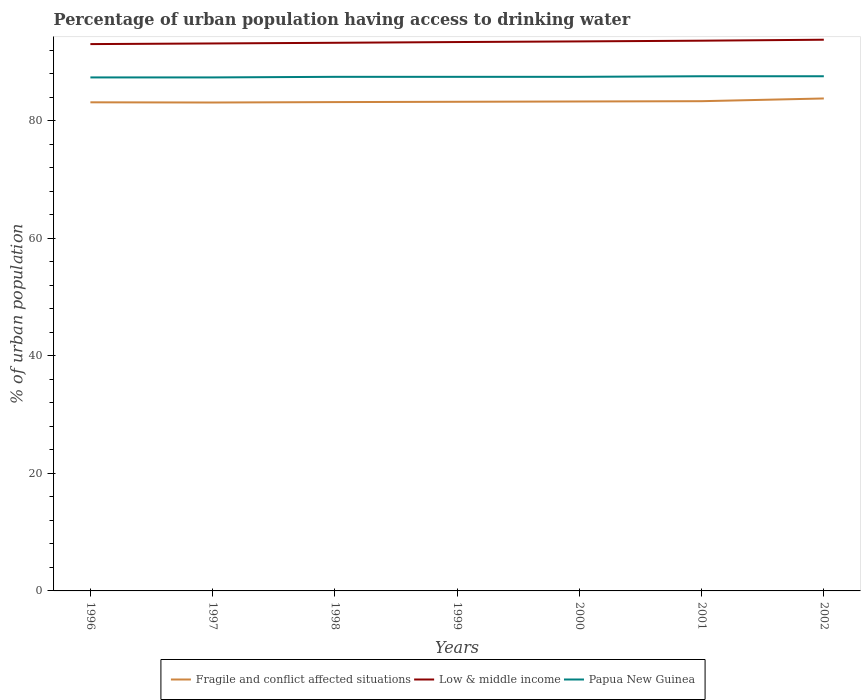Across all years, what is the maximum percentage of urban population having access to drinking water in Fragile and conflict affected situations?
Ensure brevity in your answer.  83.13. What is the total percentage of urban population having access to drinking water in Papua New Guinea in the graph?
Give a very brief answer. -0.1. What is the difference between the highest and the second highest percentage of urban population having access to drinking water in Fragile and conflict affected situations?
Give a very brief answer. 0.69. How many years are there in the graph?
Your answer should be very brief. 7. Does the graph contain grids?
Your response must be concise. No. How many legend labels are there?
Keep it short and to the point. 3. What is the title of the graph?
Your answer should be very brief. Percentage of urban population having access to drinking water. What is the label or title of the X-axis?
Keep it short and to the point. Years. What is the label or title of the Y-axis?
Keep it short and to the point. % of urban population. What is the % of urban population in Fragile and conflict affected situations in 1996?
Provide a short and direct response. 83.16. What is the % of urban population in Low & middle income in 1996?
Your answer should be very brief. 93.07. What is the % of urban population of Papua New Guinea in 1996?
Provide a short and direct response. 87.4. What is the % of urban population in Fragile and conflict affected situations in 1997?
Your answer should be very brief. 83.13. What is the % of urban population in Low & middle income in 1997?
Ensure brevity in your answer.  93.18. What is the % of urban population of Papua New Guinea in 1997?
Offer a terse response. 87.4. What is the % of urban population in Fragile and conflict affected situations in 1998?
Offer a terse response. 83.2. What is the % of urban population in Low & middle income in 1998?
Give a very brief answer. 93.3. What is the % of urban population of Papua New Guinea in 1998?
Your response must be concise. 87.5. What is the % of urban population of Fragile and conflict affected situations in 1999?
Keep it short and to the point. 83.25. What is the % of urban population in Low & middle income in 1999?
Your answer should be compact. 93.42. What is the % of urban population of Papua New Guinea in 1999?
Offer a very short reply. 87.5. What is the % of urban population in Fragile and conflict affected situations in 2000?
Keep it short and to the point. 83.31. What is the % of urban population in Low & middle income in 2000?
Keep it short and to the point. 93.53. What is the % of urban population in Papua New Guinea in 2000?
Keep it short and to the point. 87.5. What is the % of urban population in Fragile and conflict affected situations in 2001?
Keep it short and to the point. 83.35. What is the % of urban population in Low & middle income in 2001?
Your answer should be compact. 93.65. What is the % of urban population in Papua New Guinea in 2001?
Provide a succinct answer. 87.6. What is the % of urban population in Fragile and conflict affected situations in 2002?
Provide a succinct answer. 83.82. What is the % of urban population in Low & middle income in 2002?
Make the answer very short. 93.82. What is the % of urban population of Papua New Guinea in 2002?
Offer a very short reply. 87.6. Across all years, what is the maximum % of urban population in Fragile and conflict affected situations?
Your answer should be very brief. 83.82. Across all years, what is the maximum % of urban population in Low & middle income?
Your answer should be very brief. 93.82. Across all years, what is the maximum % of urban population in Papua New Guinea?
Offer a very short reply. 87.6. Across all years, what is the minimum % of urban population of Fragile and conflict affected situations?
Your answer should be very brief. 83.13. Across all years, what is the minimum % of urban population in Low & middle income?
Your response must be concise. 93.07. Across all years, what is the minimum % of urban population of Papua New Guinea?
Provide a short and direct response. 87.4. What is the total % of urban population in Fragile and conflict affected situations in the graph?
Ensure brevity in your answer.  583.23. What is the total % of urban population in Low & middle income in the graph?
Provide a short and direct response. 653.97. What is the total % of urban population in Papua New Guinea in the graph?
Provide a short and direct response. 612.5. What is the difference between the % of urban population in Fragile and conflict affected situations in 1996 and that in 1997?
Your answer should be compact. 0.04. What is the difference between the % of urban population of Low & middle income in 1996 and that in 1997?
Your answer should be very brief. -0.11. What is the difference between the % of urban population in Papua New Guinea in 1996 and that in 1997?
Give a very brief answer. 0. What is the difference between the % of urban population of Fragile and conflict affected situations in 1996 and that in 1998?
Your answer should be very brief. -0.04. What is the difference between the % of urban population in Low & middle income in 1996 and that in 1998?
Your response must be concise. -0.22. What is the difference between the % of urban population in Fragile and conflict affected situations in 1996 and that in 1999?
Ensure brevity in your answer.  -0.09. What is the difference between the % of urban population of Low & middle income in 1996 and that in 1999?
Ensure brevity in your answer.  -0.35. What is the difference between the % of urban population of Papua New Guinea in 1996 and that in 1999?
Your response must be concise. -0.1. What is the difference between the % of urban population in Fragile and conflict affected situations in 1996 and that in 2000?
Give a very brief answer. -0.14. What is the difference between the % of urban population of Low & middle income in 1996 and that in 2000?
Offer a very short reply. -0.46. What is the difference between the % of urban population in Papua New Guinea in 1996 and that in 2000?
Your answer should be compact. -0.1. What is the difference between the % of urban population of Fragile and conflict affected situations in 1996 and that in 2001?
Your response must be concise. -0.19. What is the difference between the % of urban population in Low & middle income in 1996 and that in 2001?
Your response must be concise. -0.58. What is the difference between the % of urban population in Fragile and conflict affected situations in 1996 and that in 2002?
Give a very brief answer. -0.65. What is the difference between the % of urban population in Low & middle income in 1996 and that in 2002?
Offer a very short reply. -0.75. What is the difference between the % of urban population in Fragile and conflict affected situations in 1997 and that in 1998?
Provide a succinct answer. -0.07. What is the difference between the % of urban population of Low & middle income in 1997 and that in 1998?
Your answer should be very brief. -0.11. What is the difference between the % of urban population in Papua New Guinea in 1997 and that in 1998?
Make the answer very short. -0.1. What is the difference between the % of urban population in Fragile and conflict affected situations in 1997 and that in 1999?
Your answer should be very brief. -0.13. What is the difference between the % of urban population of Low & middle income in 1997 and that in 1999?
Provide a succinct answer. -0.24. What is the difference between the % of urban population in Papua New Guinea in 1997 and that in 1999?
Make the answer very short. -0.1. What is the difference between the % of urban population of Fragile and conflict affected situations in 1997 and that in 2000?
Your answer should be very brief. -0.18. What is the difference between the % of urban population of Low & middle income in 1997 and that in 2000?
Your answer should be compact. -0.35. What is the difference between the % of urban population in Papua New Guinea in 1997 and that in 2000?
Your response must be concise. -0.1. What is the difference between the % of urban population of Fragile and conflict affected situations in 1997 and that in 2001?
Provide a succinct answer. -0.23. What is the difference between the % of urban population in Low & middle income in 1997 and that in 2001?
Your answer should be very brief. -0.47. What is the difference between the % of urban population in Papua New Guinea in 1997 and that in 2001?
Your response must be concise. -0.2. What is the difference between the % of urban population in Fragile and conflict affected situations in 1997 and that in 2002?
Keep it short and to the point. -0.69. What is the difference between the % of urban population in Low & middle income in 1997 and that in 2002?
Give a very brief answer. -0.64. What is the difference between the % of urban population in Papua New Guinea in 1997 and that in 2002?
Offer a very short reply. -0.2. What is the difference between the % of urban population in Fragile and conflict affected situations in 1998 and that in 1999?
Your answer should be very brief. -0.05. What is the difference between the % of urban population in Low & middle income in 1998 and that in 1999?
Make the answer very short. -0.12. What is the difference between the % of urban population in Papua New Guinea in 1998 and that in 1999?
Your answer should be compact. 0. What is the difference between the % of urban population in Fragile and conflict affected situations in 1998 and that in 2000?
Offer a terse response. -0.1. What is the difference between the % of urban population of Low & middle income in 1998 and that in 2000?
Provide a succinct answer. -0.23. What is the difference between the % of urban population in Fragile and conflict affected situations in 1998 and that in 2001?
Keep it short and to the point. -0.15. What is the difference between the % of urban population in Low & middle income in 1998 and that in 2001?
Ensure brevity in your answer.  -0.35. What is the difference between the % of urban population of Papua New Guinea in 1998 and that in 2001?
Provide a succinct answer. -0.1. What is the difference between the % of urban population of Fragile and conflict affected situations in 1998 and that in 2002?
Keep it short and to the point. -0.62. What is the difference between the % of urban population of Low & middle income in 1998 and that in 2002?
Your answer should be compact. -0.52. What is the difference between the % of urban population in Papua New Guinea in 1998 and that in 2002?
Offer a very short reply. -0.1. What is the difference between the % of urban population of Fragile and conflict affected situations in 1999 and that in 2000?
Keep it short and to the point. -0.05. What is the difference between the % of urban population of Low & middle income in 1999 and that in 2000?
Provide a short and direct response. -0.11. What is the difference between the % of urban population of Papua New Guinea in 1999 and that in 2000?
Ensure brevity in your answer.  0. What is the difference between the % of urban population in Fragile and conflict affected situations in 1999 and that in 2001?
Provide a succinct answer. -0.1. What is the difference between the % of urban population in Low & middle income in 1999 and that in 2001?
Ensure brevity in your answer.  -0.23. What is the difference between the % of urban population in Fragile and conflict affected situations in 1999 and that in 2002?
Give a very brief answer. -0.56. What is the difference between the % of urban population in Low & middle income in 1999 and that in 2002?
Provide a short and direct response. -0.4. What is the difference between the % of urban population of Papua New Guinea in 1999 and that in 2002?
Your answer should be very brief. -0.1. What is the difference between the % of urban population in Fragile and conflict affected situations in 2000 and that in 2001?
Your answer should be very brief. -0.05. What is the difference between the % of urban population in Low & middle income in 2000 and that in 2001?
Provide a succinct answer. -0.12. What is the difference between the % of urban population of Fragile and conflict affected situations in 2000 and that in 2002?
Provide a succinct answer. -0.51. What is the difference between the % of urban population in Low & middle income in 2000 and that in 2002?
Your response must be concise. -0.29. What is the difference between the % of urban population in Fragile and conflict affected situations in 2001 and that in 2002?
Provide a short and direct response. -0.46. What is the difference between the % of urban population in Fragile and conflict affected situations in 1996 and the % of urban population in Low & middle income in 1997?
Keep it short and to the point. -10.02. What is the difference between the % of urban population of Fragile and conflict affected situations in 1996 and the % of urban population of Papua New Guinea in 1997?
Provide a succinct answer. -4.24. What is the difference between the % of urban population in Low & middle income in 1996 and the % of urban population in Papua New Guinea in 1997?
Provide a succinct answer. 5.67. What is the difference between the % of urban population in Fragile and conflict affected situations in 1996 and the % of urban population in Low & middle income in 1998?
Ensure brevity in your answer.  -10.13. What is the difference between the % of urban population of Fragile and conflict affected situations in 1996 and the % of urban population of Papua New Guinea in 1998?
Ensure brevity in your answer.  -4.34. What is the difference between the % of urban population in Low & middle income in 1996 and the % of urban population in Papua New Guinea in 1998?
Provide a succinct answer. 5.57. What is the difference between the % of urban population of Fragile and conflict affected situations in 1996 and the % of urban population of Low & middle income in 1999?
Your response must be concise. -10.26. What is the difference between the % of urban population in Fragile and conflict affected situations in 1996 and the % of urban population in Papua New Guinea in 1999?
Ensure brevity in your answer.  -4.34. What is the difference between the % of urban population in Low & middle income in 1996 and the % of urban population in Papua New Guinea in 1999?
Provide a succinct answer. 5.57. What is the difference between the % of urban population of Fragile and conflict affected situations in 1996 and the % of urban population of Low & middle income in 2000?
Give a very brief answer. -10.37. What is the difference between the % of urban population in Fragile and conflict affected situations in 1996 and the % of urban population in Papua New Guinea in 2000?
Ensure brevity in your answer.  -4.34. What is the difference between the % of urban population of Low & middle income in 1996 and the % of urban population of Papua New Guinea in 2000?
Provide a short and direct response. 5.57. What is the difference between the % of urban population in Fragile and conflict affected situations in 1996 and the % of urban population in Low & middle income in 2001?
Ensure brevity in your answer.  -10.49. What is the difference between the % of urban population in Fragile and conflict affected situations in 1996 and the % of urban population in Papua New Guinea in 2001?
Your response must be concise. -4.44. What is the difference between the % of urban population in Low & middle income in 1996 and the % of urban population in Papua New Guinea in 2001?
Keep it short and to the point. 5.47. What is the difference between the % of urban population of Fragile and conflict affected situations in 1996 and the % of urban population of Low & middle income in 2002?
Your answer should be compact. -10.65. What is the difference between the % of urban population of Fragile and conflict affected situations in 1996 and the % of urban population of Papua New Guinea in 2002?
Offer a terse response. -4.44. What is the difference between the % of urban population in Low & middle income in 1996 and the % of urban population in Papua New Guinea in 2002?
Keep it short and to the point. 5.47. What is the difference between the % of urban population of Fragile and conflict affected situations in 1997 and the % of urban population of Low & middle income in 1998?
Your response must be concise. -10.17. What is the difference between the % of urban population in Fragile and conflict affected situations in 1997 and the % of urban population in Papua New Guinea in 1998?
Your answer should be compact. -4.37. What is the difference between the % of urban population in Low & middle income in 1997 and the % of urban population in Papua New Guinea in 1998?
Provide a succinct answer. 5.68. What is the difference between the % of urban population of Fragile and conflict affected situations in 1997 and the % of urban population of Low & middle income in 1999?
Your answer should be very brief. -10.29. What is the difference between the % of urban population in Fragile and conflict affected situations in 1997 and the % of urban population in Papua New Guinea in 1999?
Keep it short and to the point. -4.37. What is the difference between the % of urban population of Low & middle income in 1997 and the % of urban population of Papua New Guinea in 1999?
Offer a terse response. 5.68. What is the difference between the % of urban population in Fragile and conflict affected situations in 1997 and the % of urban population in Low & middle income in 2000?
Your answer should be very brief. -10.4. What is the difference between the % of urban population of Fragile and conflict affected situations in 1997 and the % of urban population of Papua New Guinea in 2000?
Make the answer very short. -4.37. What is the difference between the % of urban population of Low & middle income in 1997 and the % of urban population of Papua New Guinea in 2000?
Give a very brief answer. 5.68. What is the difference between the % of urban population of Fragile and conflict affected situations in 1997 and the % of urban population of Low & middle income in 2001?
Give a very brief answer. -10.52. What is the difference between the % of urban population of Fragile and conflict affected situations in 1997 and the % of urban population of Papua New Guinea in 2001?
Give a very brief answer. -4.47. What is the difference between the % of urban population in Low & middle income in 1997 and the % of urban population in Papua New Guinea in 2001?
Provide a succinct answer. 5.58. What is the difference between the % of urban population of Fragile and conflict affected situations in 1997 and the % of urban population of Low & middle income in 2002?
Provide a succinct answer. -10.69. What is the difference between the % of urban population of Fragile and conflict affected situations in 1997 and the % of urban population of Papua New Guinea in 2002?
Ensure brevity in your answer.  -4.47. What is the difference between the % of urban population in Low & middle income in 1997 and the % of urban population in Papua New Guinea in 2002?
Give a very brief answer. 5.58. What is the difference between the % of urban population in Fragile and conflict affected situations in 1998 and the % of urban population in Low & middle income in 1999?
Offer a terse response. -10.22. What is the difference between the % of urban population of Fragile and conflict affected situations in 1998 and the % of urban population of Papua New Guinea in 1999?
Keep it short and to the point. -4.3. What is the difference between the % of urban population of Low & middle income in 1998 and the % of urban population of Papua New Guinea in 1999?
Give a very brief answer. 5.8. What is the difference between the % of urban population of Fragile and conflict affected situations in 1998 and the % of urban population of Low & middle income in 2000?
Give a very brief answer. -10.33. What is the difference between the % of urban population of Fragile and conflict affected situations in 1998 and the % of urban population of Papua New Guinea in 2000?
Keep it short and to the point. -4.3. What is the difference between the % of urban population in Low & middle income in 1998 and the % of urban population in Papua New Guinea in 2000?
Offer a terse response. 5.8. What is the difference between the % of urban population in Fragile and conflict affected situations in 1998 and the % of urban population in Low & middle income in 2001?
Make the answer very short. -10.45. What is the difference between the % of urban population of Fragile and conflict affected situations in 1998 and the % of urban population of Papua New Guinea in 2001?
Offer a very short reply. -4.4. What is the difference between the % of urban population of Low & middle income in 1998 and the % of urban population of Papua New Guinea in 2001?
Give a very brief answer. 5.7. What is the difference between the % of urban population of Fragile and conflict affected situations in 1998 and the % of urban population of Low & middle income in 2002?
Your answer should be very brief. -10.62. What is the difference between the % of urban population in Fragile and conflict affected situations in 1998 and the % of urban population in Papua New Guinea in 2002?
Offer a terse response. -4.4. What is the difference between the % of urban population of Low & middle income in 1998 and the % of urban population of Papua New Guinea in 2002?
Make the answer very short. 5.7. What is the difference between the % of urban population in Fragile and conflict affected situations in 1999 and the % of urban population in Low & middle income in 2000?
Your answer should be compact. -10.28. What is the difference between the % of urban population in Fragile and conflict affected situations in 1999 and the % of urban population in Papua New Guinea in 2000?
Your answer should be compact. -4.25. What is the difference between the % of urban population in Low & middle income in 1999 and the % of urban population in Papua New Guinea in 2000?
Provide a succinct answer. 5.92. What is the difference between the % of urban population of Fragile and conflict affected situations in 1999 and the % of urban population of Low & middle income in 2001?
Keep it short and to the point. -10.4. What is the difference between the % of urban population of Fragile and conflict affected situations in 1999 and the % of urban population of Papua New Guinea in 2001?
Ensure brevity in your answer.  -4.35. What is the difference between the % of urban population of Low & middle income in 1999 and the % of urban population of Papua New Guinea in 2001?
Offer a very short reply. 5.82. What is the difference between the % of urban population in Fragile and conflict affected situations in 1999 and the % of urban population in Low & middle income in 2002?
Offer a terse response. -10.56. What is the difference between the % of urban population in Fragile and conflict affected situations in 1999 and the % of urban population in Papua New Guinea in 2002?
Provide a succinct answer. -4.35. What is the difference between the % of urban population of Low & middle income in 1999 and the % of urban population of Papua New Guinea in 2002?
Give a very brief answer. 5.82. What is the difference between the % of urban population of Fragile and conflict affected situations in 2000 and the % of urban population of Low & middle income in 2001?
Provide a short and direct response. -10.35. What is the difference between the % of urban population in Fragile and conflict affected situations in 2000 and the % of urban population in Papua New Guinea in 2001?
Offer a very short reply. -4.29. What is the difference between the % of urban population in Low & middle income in 2000 and the % of urban population in Papua New Guinea in 2001?
Offer a very short reply. 5.93. What is the difference between the % of urban population of Fragile and conflict affected situations in 2000 and the % of urban population of Low & middle income in 2002?
Ensure brevity in your answer.  -10.51. What is the difference between the % of urban population of Fragile and conflict affected situations in 2000 and the % of urban population of Papua New Guinea in 2002?
Your answer should be compact. -4.29. What is the difference between the % of urban population in Low & middle income in 2000 and the % of urban population in Papua New Guinea in 2002?
Provide a succinct answer. 5.93. What is the difference between the % of urban population in Fragile and conflict affected situations in 2001 and the % of urban population in Low & middle income in 2002?
Give a very brief answer. -10.46. What is the difference between the % of urban population of Fragile and conflict affected situations in 2001 and the % of urban population of Papua New Guinea in 2002?
Your response must be concise. -4.25. What is the difference between the % of urban population of Low & middle income in 2001 and the % of urban population of Papua New Guinea in 2002?
Keep it short and to the point. 6.05. What is the average % of urban population of Fragile and conflict affected situations per year?
Offer a very short reply. 83.32. What is the average % of urban population in Low & middle income per year?
Ensure brevity in your answer.  93.42. What is the average % of urban population of Papua New Guinea per year?
Offer a very short reply. 87.5. In the year 1996, what is the difference between the % of urban population in Fragile and conflict affected situations and % of urban population in Low & middle income?
Provide a short and direct response. -9.91. In the year 1996, what is the difference between the % of urban population in Fragile and conflict affected situations and % of urban population in Papua New Guinea?
Offer a terse response. -4.24. In the year 1996, what is the difference between the % of urban population of Low & middle income and % of urban population of Papua New Guinea?
Offer a very short reply. 5.67. In the year 1997, what is the difference between the % of urban population of Fragile and conflict affected situations and % of urban population of Low & middle income?
Give a very brief answer. -10.05. In the year 1997, what is the difference between the % of urban population of Fragile and conflict affected situations and % of urban population of Papua New Guinea?
Provide a short and direct response. -4.27. In the year 1997, what is the difference between the % of urban population of Low & middle income and % of urban population of Papua New Guinea?
Offer a terse response. 5.78. In the year 1998, what is the difference between the % of urban population in Fragile and conflict affected situations and % of urban population in Low & middle income?
Ensure brevity in your answer.  -10.09. In the year 1998, what is the difference between the % of urban population in Fragile and conflict affected situations and % of urban population in Papua New Guinea?
Your response must be concise. -4.3. In the year 1998, what is the difference between the % of urban population in Low & middle income and % of urban population in Papua New Guinea?
Ensure brevity in your answer.  5.8. In the year 1999, what is the difference between the % of urban population of Fragile and conflict affected situations and % of urban population of Low & middle income?
Provide a short and direct response. -10.17. In the year 1999, what is the difference between the % of urban population in Fragile and conflict affected situations and % of urban population in Papua New Guinea?
Offer a terse response. -4.25. In the year 1999, what is the difference between the % of urban population in Low & middle income and % of urban population in Papua New Guinea?
Ensure brevity in your answer.  5.92. In the year 2000, what is the difference between the % of urban population of Fragile and conflict affected situations and % of urban population of Low & middle income?
Offer a very short reply. -10.22. In the year 2000, what is the difference between the % of urban population in Fragile and conflict affected situations and % of urban population in Papua New Guinea?
Make the answer very short. -4.19. In the year 2000, what is the difference between the % of urban population of Low & middle income and % of urban population of Papua New Guinea?
Ensure brevity in your answer.  6.03. In the year 2001, what is the difference between the % of urban population of Fragile and conflict affected situations and % of urban population of Low & middle income?
Offer a very short reply. -10.3. In the year 2001, what is the difference between the % of urban population in Fragile and conflict affected situations and % of urban population in Papua New Guinea?
Make the answer very short. -4.25. In the year 2001, what is the difference between the % of urban population of Low & middle income and % of urban population of Papua New Guinea?
Keep it short and to the point. 6.05. In the year 2002, what is the difference between the % of urban population of Fragile and conflict affected situations and % of urban population of Low & middle income?
Provide a short and direct response. -10. In the year 2002, what is the difference between the % of urban population in Fragile and conflict affected situations and % of urban population in Papua New Guinea?
Give a very brief answer. -3.78. In the year 2002, what is the difference between the % of urban population of Low & middle income and % of urban population of Papua New Guinea?
Offer a very short reply. 6.22. What is the ratio of the % of urban population of Fragile and conflict affected situations in 1996 to that in 1997?
Give a very brief answer. 1. What is the ratio of the % of urban population in Low & middle income in 1996 to that in 1998?
Keep it short and to the point. 1. What is the ratio of the % of urban population of Papua New Guinea in 1996 to that in 1998?
Make the answer very short. 1. What is the ratio of the % of urban population in Low & middle income in 1996 to that in 1999?
Provide a short and direct response. 1. What is the ratio of the % of urban population of Fragile and conflict affected situations in 1996 to that in 2000?
Make the answer very short. 1. What is the ratio of the % of urban population in Low & middle income in 1996 to that in 2002?
Provide a succinct answer. 0.99. What is the ratio of the % of urban population of Papua New Guinea in 1996 to that in 2002?
Offer a terse response. 1. What is the ratio of the % of urban population of Papua New Guinea in 1997 to that in 1998?
Offer a very short reply. 1. What is the ratio of the % of urban population in Papua New Guinea in 1997 to that in 1999?
Provide a short and direct response. 1. What is the ratio of the % of urban population in Papua New Guinea in 1997 to that in 2001?
Offer a very short reply. 1. What is the ratio of the % of urban population of Fragile and conflict affected situations in 1997 to that in 2002?
Offer a very short reply. 0.99. What is the ratio of the % of urban population in Fragile and conflict affected situations in 1998 to that in 1999?
Provide a short and direct response. 1. What is the ratio of the % of urban population of Low & middle income in 1998 to that in 1999?
Offer a very short reply. 1. What is the ratio of the % of urban population in Fragile and conflict affected situations in 1998 to that in 2000?
Ensure brevity in your answer.  1. What is the ratio of the % of urban population in Fragile and conflict affected situations in 1998 to that in 2001?
Your response must be concise. 1. What is the ratio of the % of urban population of Low & middle income in 1998 to that in 2001?
Ensure brevity in your answer.  1. What is the ratio of the % of urban population in Papua New Guinea in 1998 to that in 2001?
Provide a succinct answer. 1. What is the ratio of the % of urban population of Fragile and conflict affected situations in 1998 to that in 2002?
Provide a short and direct response. 0.99. What is the ratio of the % of urban population of Papua New Guinea in 1998 to that in 2002?
Keep it short and to the point. 1. What is the ratio of the % of urban population of Low & middle income in 1999 to that in 2000?
Provide a succinct answer. 1. What is the ratio of the % of urban population of Papua New Guinea in 1999 to that in 2001?
Provide a succinct answer. 1. What is the ratio of the % of urban population in Fragile and conflict affected situations in 2000 to that in 2001?
Your answer should be very brief. 1. What is the ratio of the % of urban population in Papua New Guinea in 2000 to that in 2002?
Give a very brief answer. 1. What is the ratio of the % of urban population in Low & middle income in 2001 to that in 2002?
Your answer should be compact. 1. What is the ratio of the % of urban population in Papua New Guinea in 2001 to that in 2002?
Your answer should be very brief. 1. What is the difference between the highest and the second highest % of urban population of Fragile and conflict affected situations?
Your response must be concise. 0.46. What is the difference between the highest and the second highest % of urban population in Low & middle income?
Offer a terse response. 0.17. What is the difference between the highest and the second highest % of urban population of Papua New Guinea?
Your response must be concise. 0. What is the difference between the highest and the lowest % of urban population in Fragile and conflict affected situations?
Your response must be concise. 0.69. What is the difference between the highest and the lowest % of urban population in Low & middle income?
Keep it short and to the point. 0.75. What is the difference between the highest and the lowest % of urban population in Papua New Guinea?
Keep it short and to the point. 0.2. 